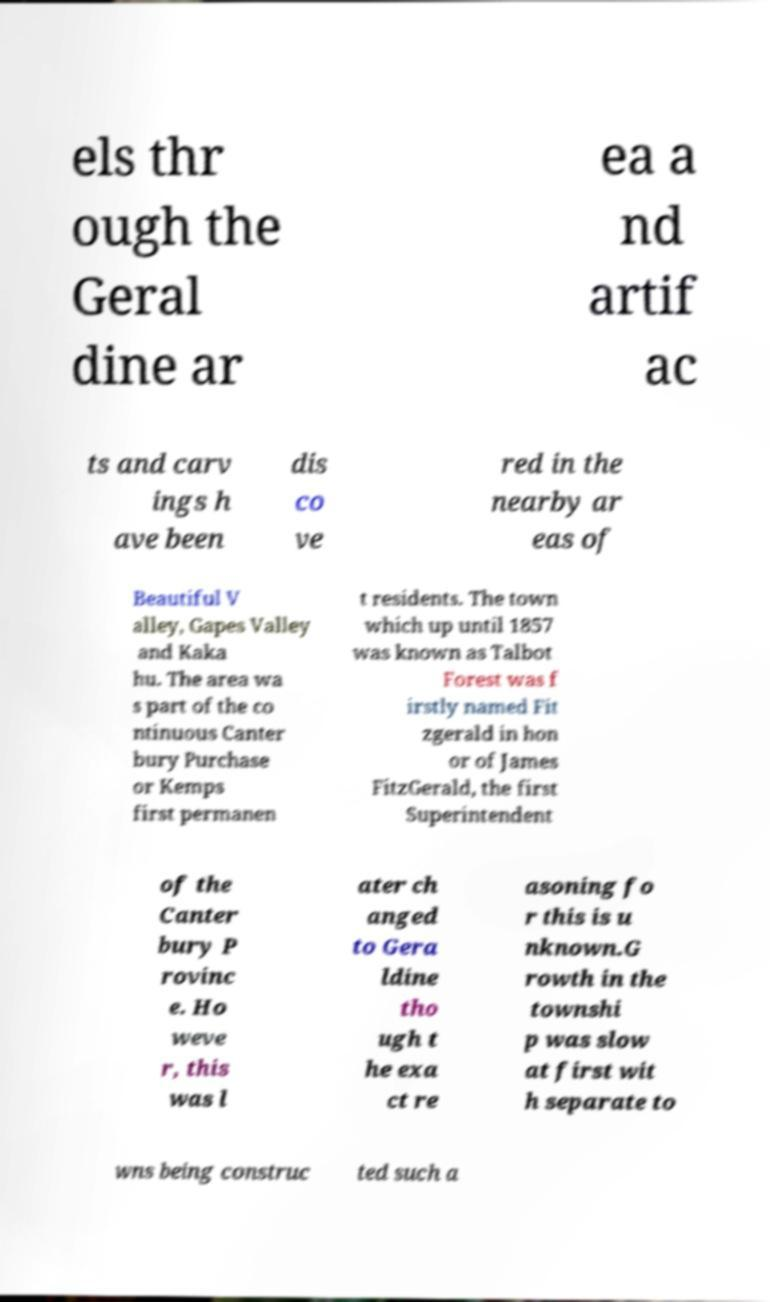I need the written content from this picture converted into text. Can you do that? els thr ough the Geral dine ar ea a nd artif ac ts and carv ings h ave been dis co ve red in the nearby ar eas of Beautiful V alley, Gapes Valley and Kaka hu. The area wa s part of the co ntinuous Canter bury Purchase or Kemps first permanen t residents. The town which up until 1857 was known as Talbot Forest was f irstly named Fit zgerald in hon or of James FitzGerald, the first Superintendent of the Canter bury P rovinc e. Ho weve r, this was l ater ch anged to Gera ldine tho ugh t he exa ct re asoning fo r this is u nknown.G rowth in the townshi p was slow at first wit h separate to wns being construc ted such a 